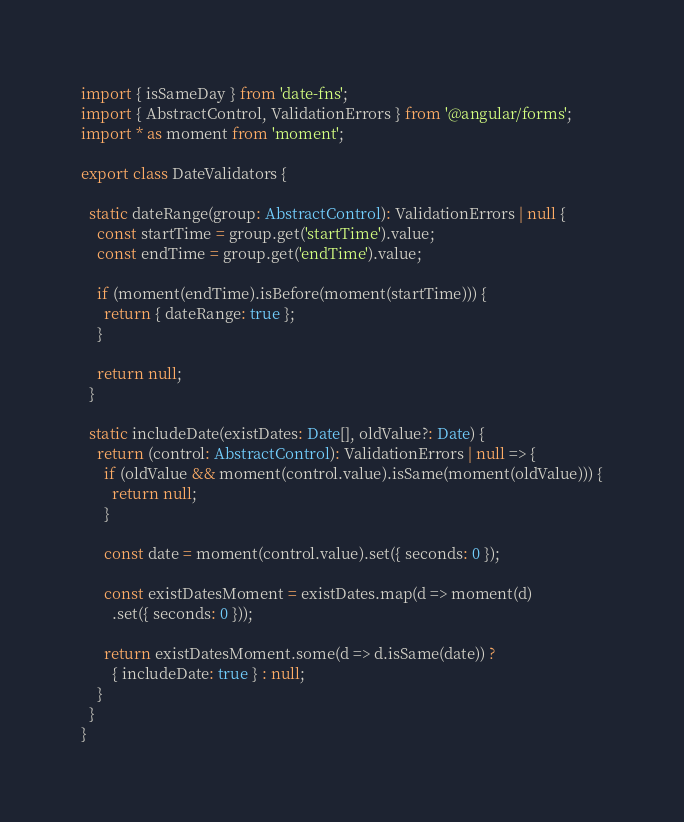<code> <loc_0><loc_0><loc_500><loc_500><_TypeScript_>import { isSameDay } from 'date-fns';
import { AbstractControl, ValidationErrors } from '@angular/forms';
import * as moment from 'moment';

export class DateValidators {

  static dateRange(group: AbstractControl): ValidationErrors | null {
    const startTime = group.get('startTime').value;
    const endTime = group.get('endTime').value;

    if (moment(endTime).isBefore(moment(startTime))) {
      return { dateRange: true };
    }

    return null;
  }

  static includeDate(existDates: Date[], oldValue?: Date) {
    return (control: AbstractControl): ValidationErrors | null => {
      if (oldValue && moment(control.value).isSame(moment(oldValue))) {
        return null;
      }

      const date = moment(control.value).set({ seconds: 0 });

      const existDatesMoment = existDates.map(d => moment(d)
        .set({ seconds: 0 }));

      return existDatesMoment.some(d => d.isSame(date)) ?
        { includeDate: true } : null;
    }
  }
}
</code> 